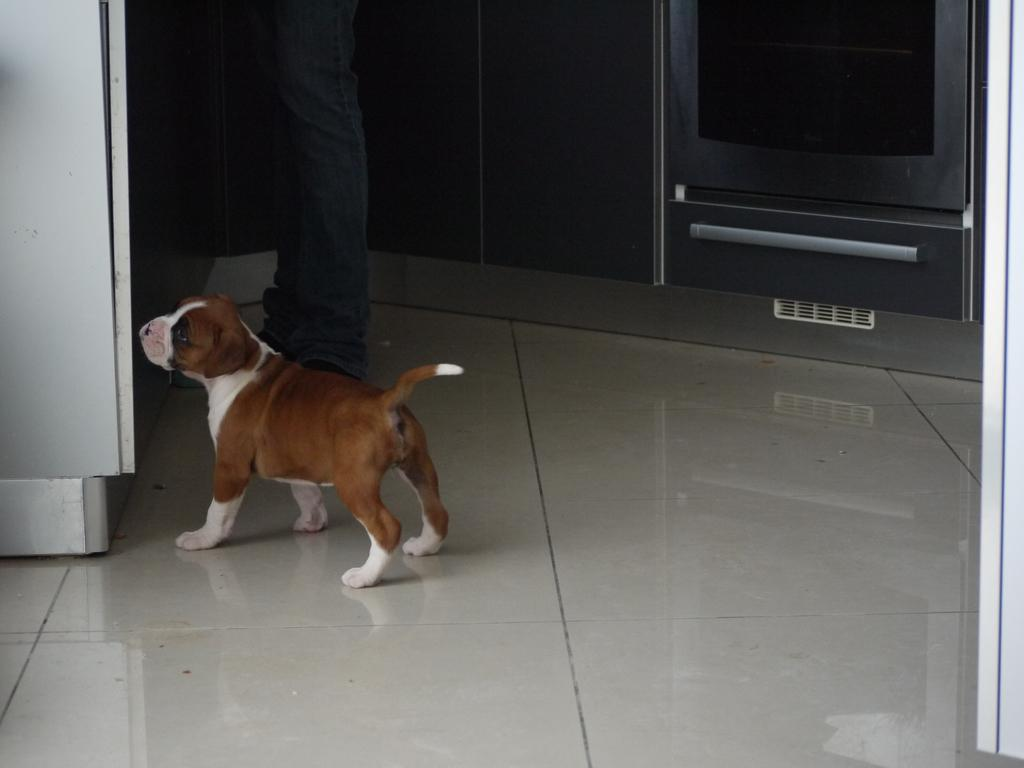What is the main subject in the center of the image? There is a dog in the center of the image. Can you identify any other living being in the image? Yes, there is a person in the image. What appliance is located on the left side of the image? There is a fridge on the left side of the image. What type of furniture is on the right side of the image? There is a cupboard on the right side of the image. What type of territory is the dog claiming in the image? There is no indication in the image that the dog is claiming any territory. 